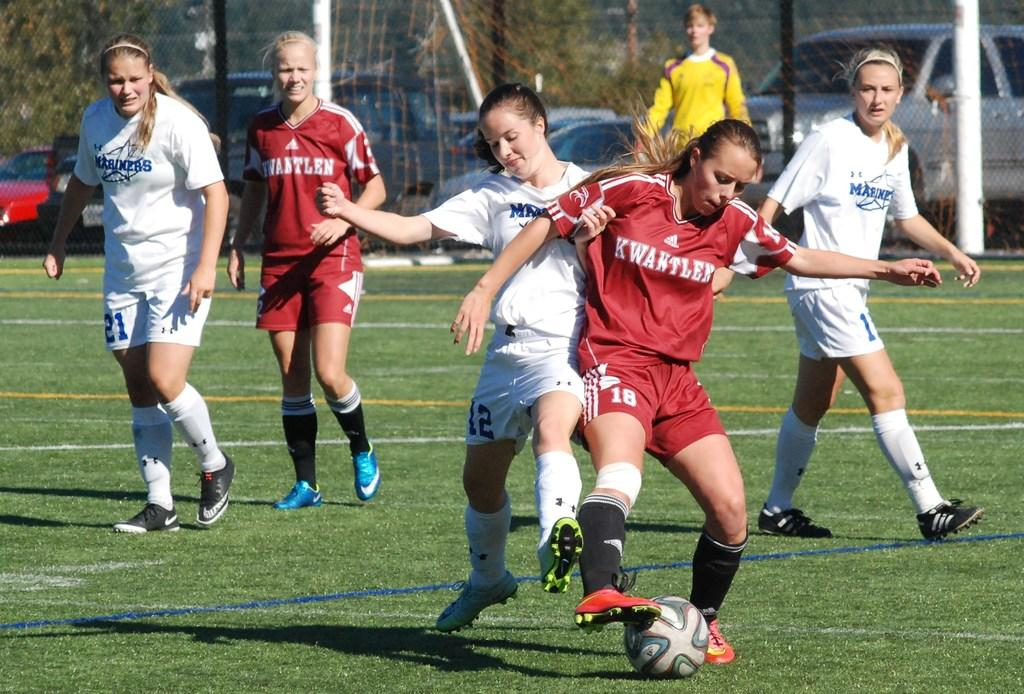How many women are present in the image? There are 7 women in the image. Where are the women located? The women are on the grass. What object can be seen in the image besides the women? There is a football in the image. What can be seen in the background of the image? There is a net, a fence, 2 poles, and cars visible in the background of the image. Are the women's sisters present in the image? The provided facts do not mention any relationships between the women, so we cannot determine if they are sisters or not. What type of rod can be seen in the image? There is no rod present in the image. 